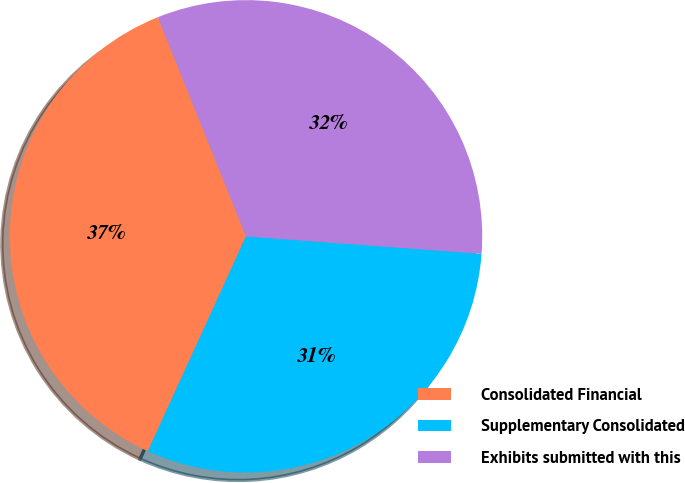Convert chart to OTSL. <chart><loc_0><loc_0><loc_500><loc_500><pie_chart><fcel>Consolidated Financial<fcel>Supplementary Consolidated<fcel>Exhibits submitted with this<nl><fcel>37.1%<fcel>30.65%<fcel>32.26%<nl></chart> 